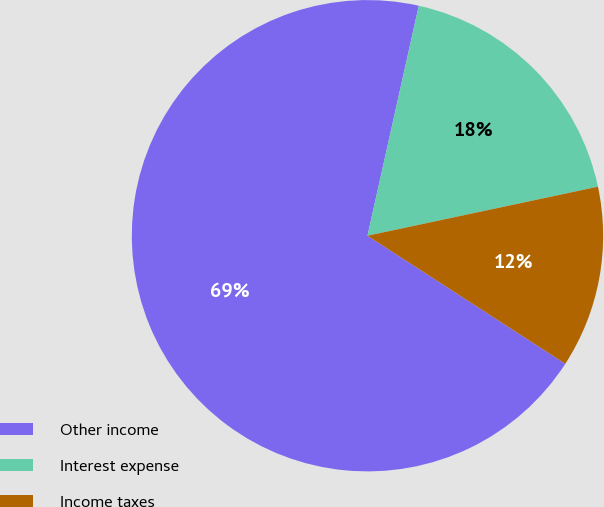Convert chart. <chart><loc_0><loc_0><loc_500><loc_500><pie_chart><fcel>Other income<fcel>Interest expense<fcel>Income taxes<nl><fcel>69.35%<fcel>18.17%<fcel>12.48%<nl></chart> 